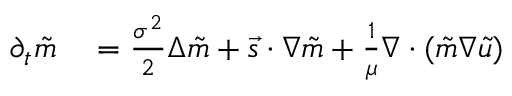Convert formula to latex. <formula><loc_0><loc_0><loc_500><loc_500>\begin{array} { r l } { \partial _ { t } \tilde { m } } & = \frac { \sigma ^ { 2 } } { 2 } \Delta \tilde { m } + \vec { s } \cdot \nabla \tilde { m } + \frac { 1 } { \mu } \nabla \cdot ( \tilde { m } \nabla \tilde { u } ) } \end{array}</formula> 